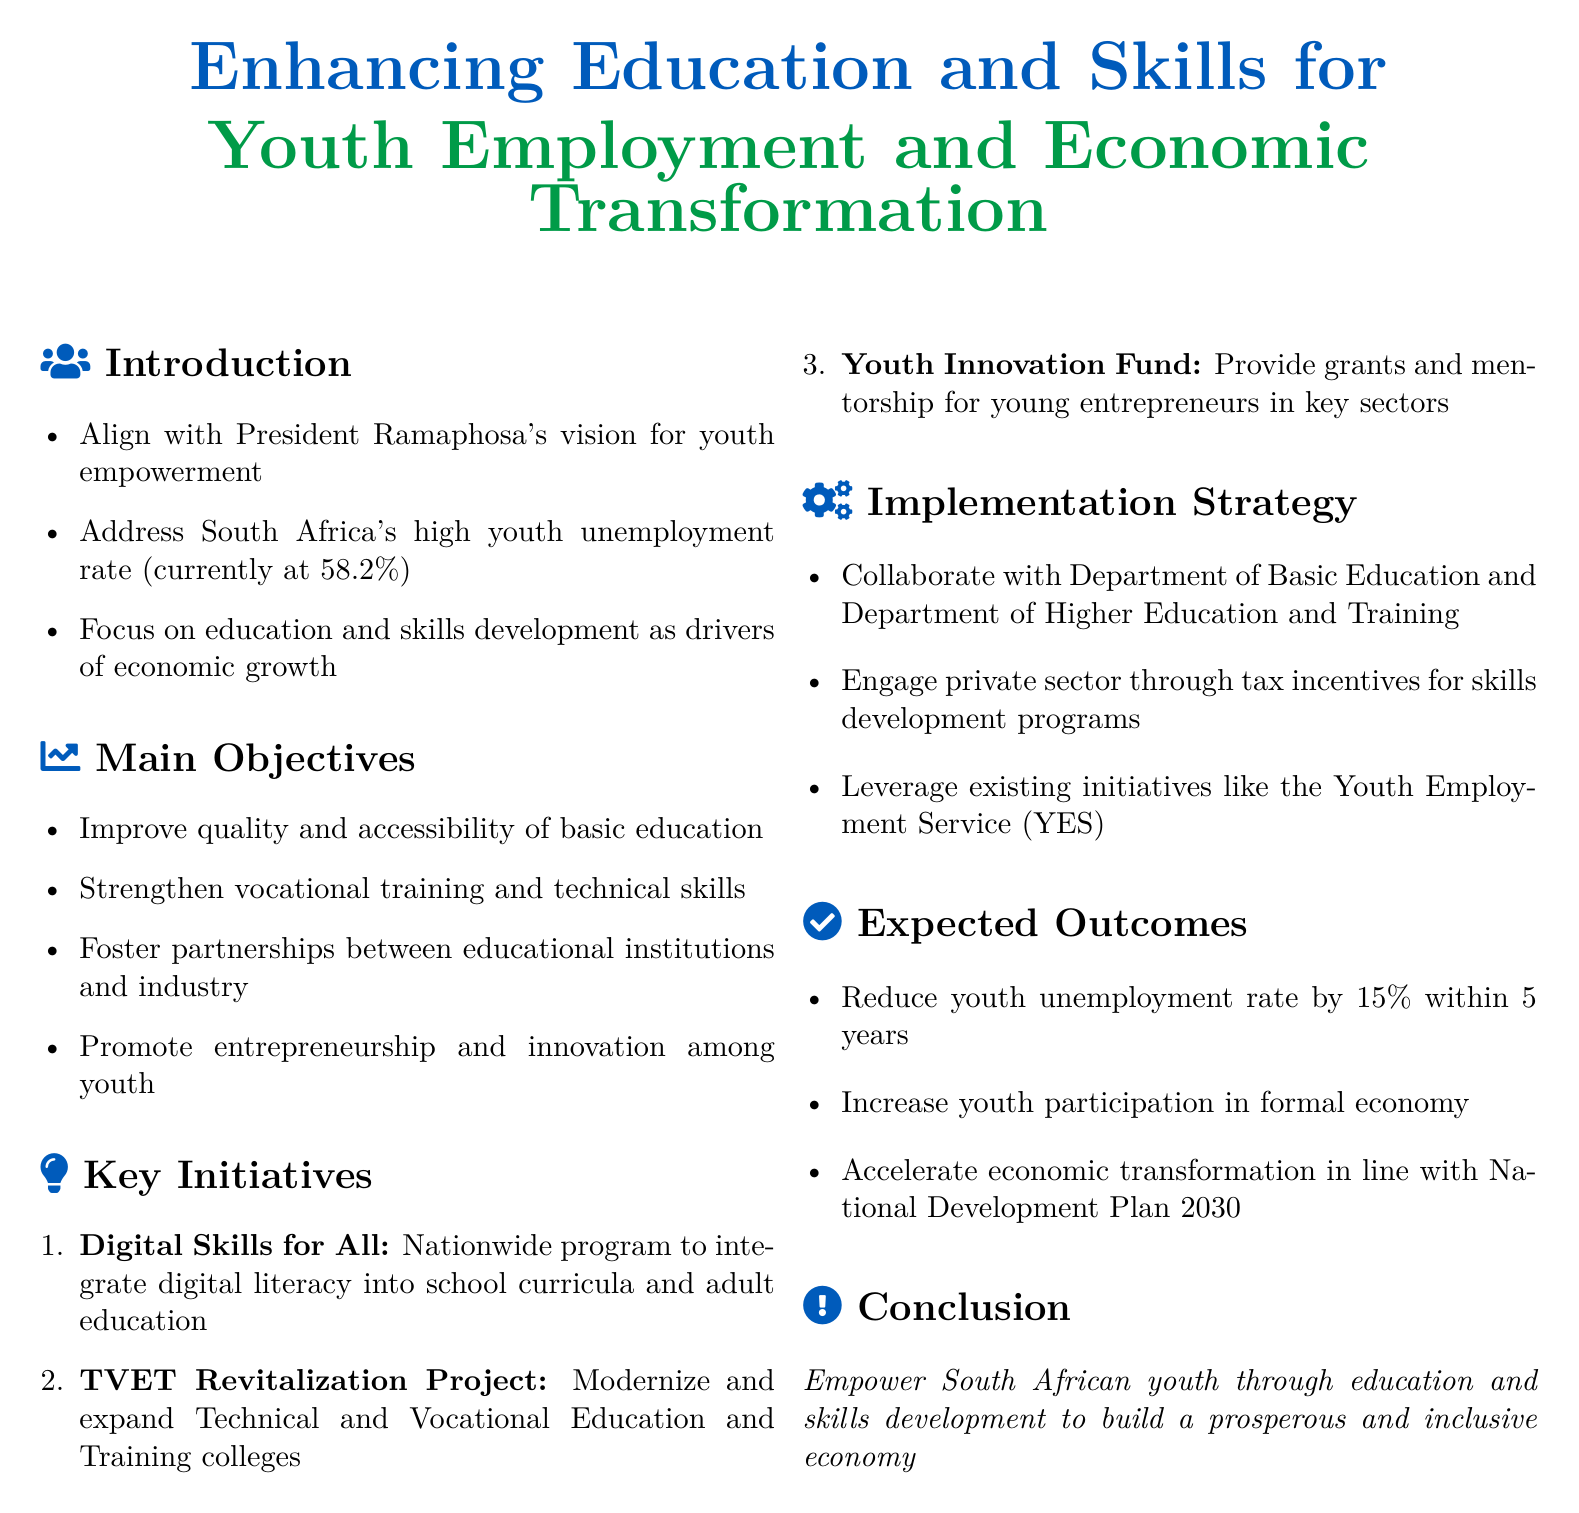What is the youth unemployment rate currently? The document states South Africa's youth unemployment rate as currently at 58.2%.
Answer: 58.2% What is one of the main objectives of the policy framework? The document lists improving the quality and accessibility of basic education as one of the main objectives.
Answer: Improve quality and accessibility of basic education What is the name of the nationwide program mentioned? The document refers to a nationwide program for integrating digital literacy as "Digital Skills for All."
Answer: Digital Skills for All How much does the framework aim to reduce youth unemployment within 5 years? According to the document, the framework aims to reduce the youth unemployment rate by 15% within 5 years.
Answer: 15% Which two departments are mentioned for collaboration in the implementation strategy? The implementation strategy mentions collaborating with the Department of Basic Education and Department of Higher Education and Training.
Answer: Department of Basic Education and Department of Higher Education and Training What is the primary focus of the key initiatives? The key initiatives are primarily focused on enhancing education and skills for youth employment.
Answer: Enhancing education and skills for youth employment What is provided through the Youth Innovation Fund? The Youth Innovation Fund provides grants and mentorship for young entrepreneurs in key sectors.
Answer: Grants and mentorship What is the primary goal of the policy framework? The primary goal of the policy framework is to empower South African youth through education and skills development.
Answer: Empower South African youth through education and skills development 